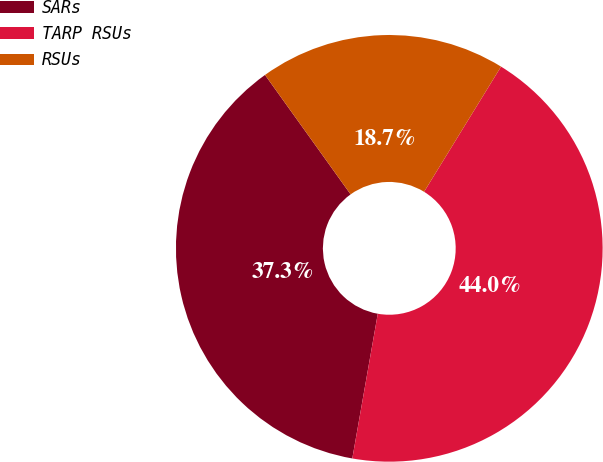<chart> <loc_0><loc_0><loc_500><loc_500><pie_chart><fcel>SARs<fcel>TARP RSUs<fcel>RSUs<nl><fcel>37.33%<fcel>44.0%<fcel>18.67%<nl></chart> 